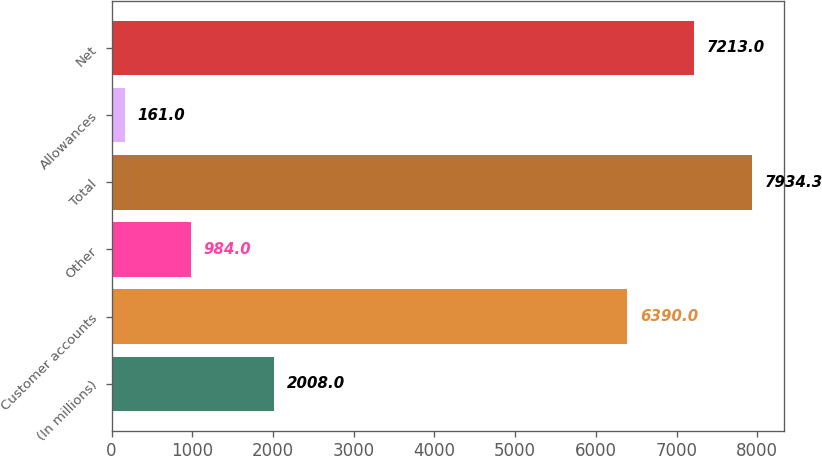<chart> <loc_0><loc_0><loc_500><loc_500><bar_chart><fcel>(In millions)<fcel>Customer accounts<fcel>Other<fcel>Total<fcel>Allowances<fcel>Net<nl><fcel>2008<fcel>6390<fcel>984<fcel>7934.3<fcel>161<fcel>7213<nl></chart> 